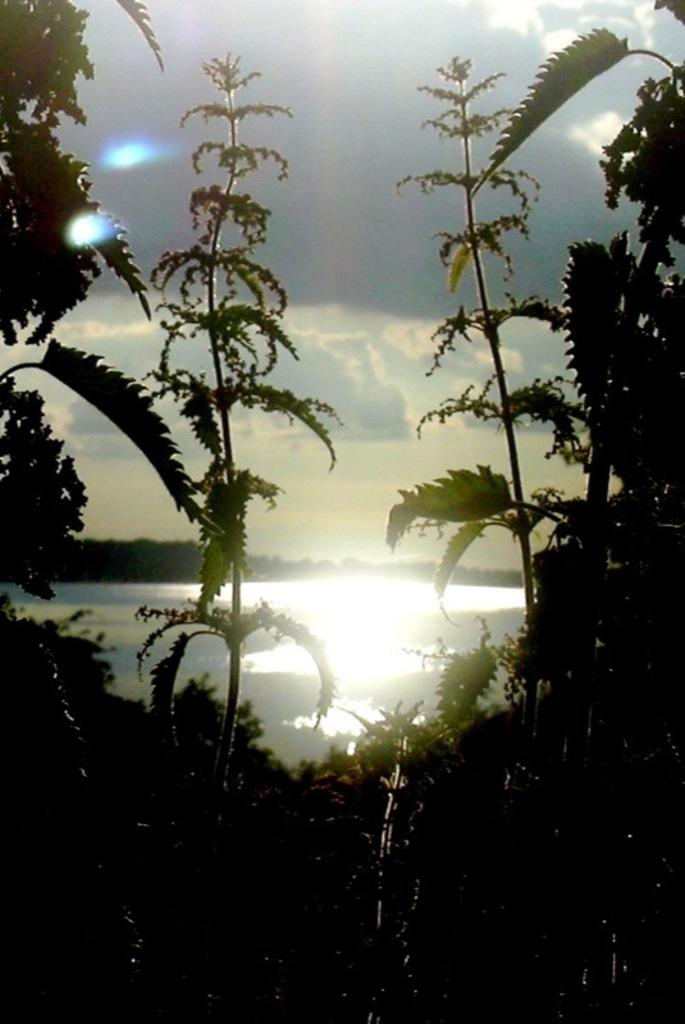What type of living organisms can be seen in the image? Plants can be seen in the image. What is visible in the background of the image? Water and clouds in the sky are visible in the background of the image. What type of sound can be heard coming from the can in the image? There is no can present in the image, so it's not possible to determine what, if any, sound might be heard. 